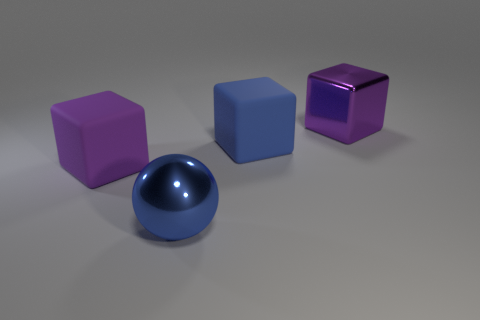Add 3 purple shiny cubes. How many objects exist? 7 Subtract all spheres. How many objects are left? 3 Add 1 large cubes. How many large cubes exist? 4 Subtract 0 purple cylinders. How many objects are left? 4 Subtract all tiny red cylinders. Subtract all large blue rubber objects. How many objects are left? 3 Add 1 shiny cubes. How many shiny cubes are left? 2 